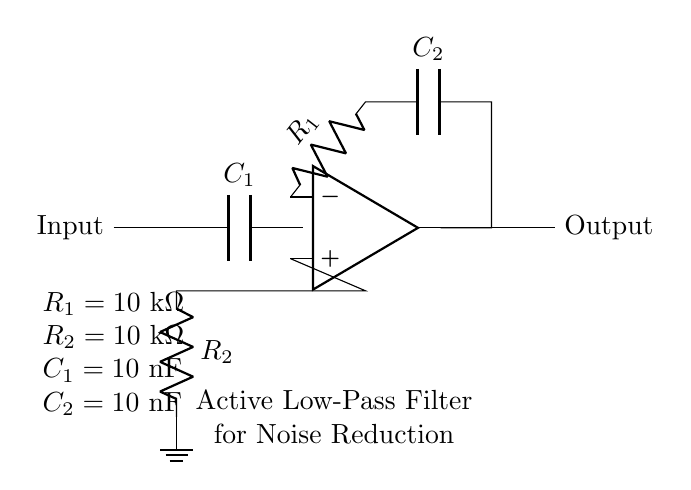What type of filter is this circuit? This circuit is an active low-pass filter, which can be identified by the arrangement of the components and the op-amp configuration designed to allow low-frequency signals while attenuating high-frequency noise.
Answer: Active low-pass filter What are the component values for R1? The component value for R1, as indicated in the circuit diagram, is 10 kΩ, which is stated next to its label in the diagram.
Answer: 10 kΩ Which components are used for feedback in this circuit? The feedback network includes R1 and C2, as seen connecting from the output of the op-amp back to its inverting input, thereby allowing the filter to function correctly.
Answer: R1 and C2 What is the total capacitance in the circuit? The total capacitance in the circuit involves C1 and C2, where both values are 10 nF each, leading to a combined effective capacitance for the filter operation, which in an ideal configuration is typically taken as 10 nF for this single-stage circuit as both operate independently.
Answer: 10 nF What is the function of the capacitor C1? Capacitor C1 is used to couple the input signal to the op-amp, allowing AC signals to pass while blocking DC, which is crucial for the noise reduction function of the filter by not allowing unwanted DC voltages to affect the input.
Answer: Coupling How does the choice of R1 and R2 affect the filter's performance? The values of R1 and R2 determine the gain of the active filter and influence the cutoff frequency alongside the capacitance values. Higher resistance values generally result in lower current draw and can therefore affect the overall filter performance by configuring the gain and bandwidth of the circuit.
Answer: Gain and bandwidth 